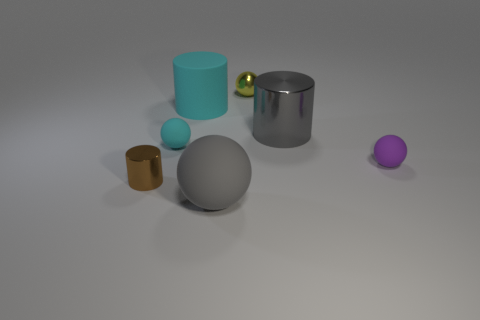What number of other things are the same color as the large rubber cylinder?
Keep it short and to the point. 1. Is the color of the shiny ball the same as the big matte sphere?
Give a very brief answer. No. There is a object that is the same color as the big matte cylinder; what material is it?
Provide a short and direct response. Rubber. There is a large cylinder on the right side of the tiny metal thing behind the tiny purple matte thing; what is its material?
Ensure brevity in your answer.  Metal. Is the number of tiny metallic cylinders to the right of the purple sphere the same as the number of tiny brown cylinders to the right of the yellow shiny sphere?
Offer a terse response. Yes. What number of objects are either objects that are behind the big sphere or tiny shiny objects behind the purple rubber thing?
Ensure brevity in your answer.  6. What is the material of the small object that is in front of the tiny cyan matte object and right of the tiny cyan matte ball?
Your answer should be compact. Rubber. There is a matte sphere that is to the right of the gray object on the right side of the small shiny object behind the tiny brown thing; what is its size?
Your answer should be very brief. Small. Is the number of tiny cyan rubber spheres greater than the number of big brown rubber spheres?
Provide a short and direct response. Yes. Is the gray object to the left of the big shiny cylinder made of the same material as the yellow sphere?
Keep it short and to the point. No. 